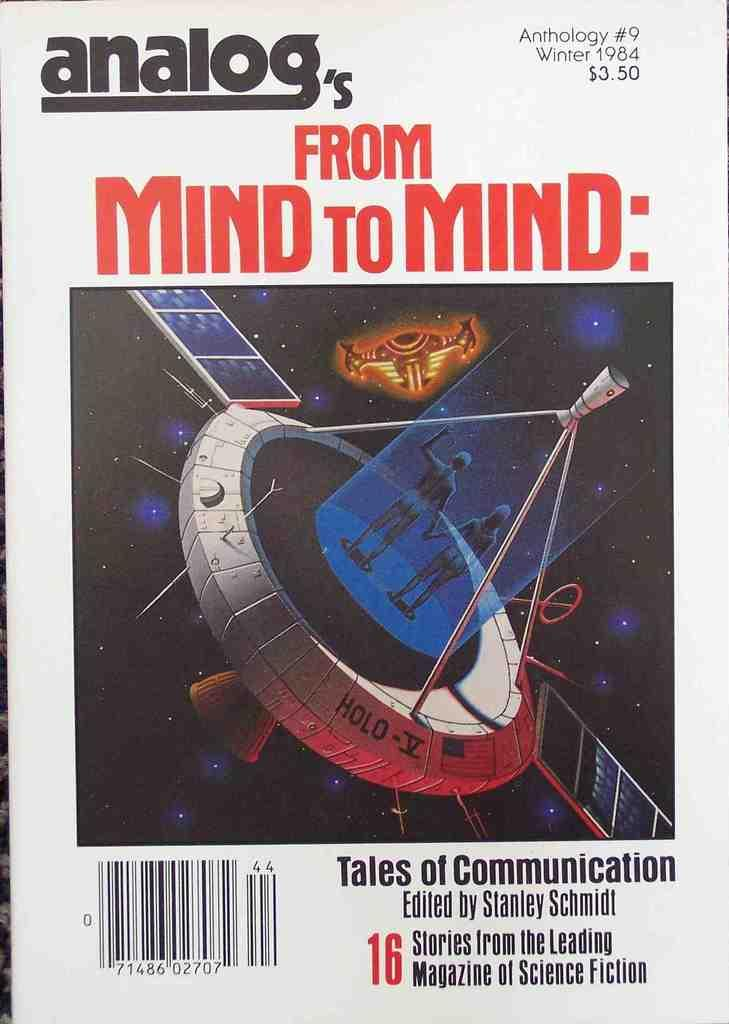<image>
Summarize the visual content of the image. Poster for "Analog's From Mind to Mind" showing two aliens holding hands. 